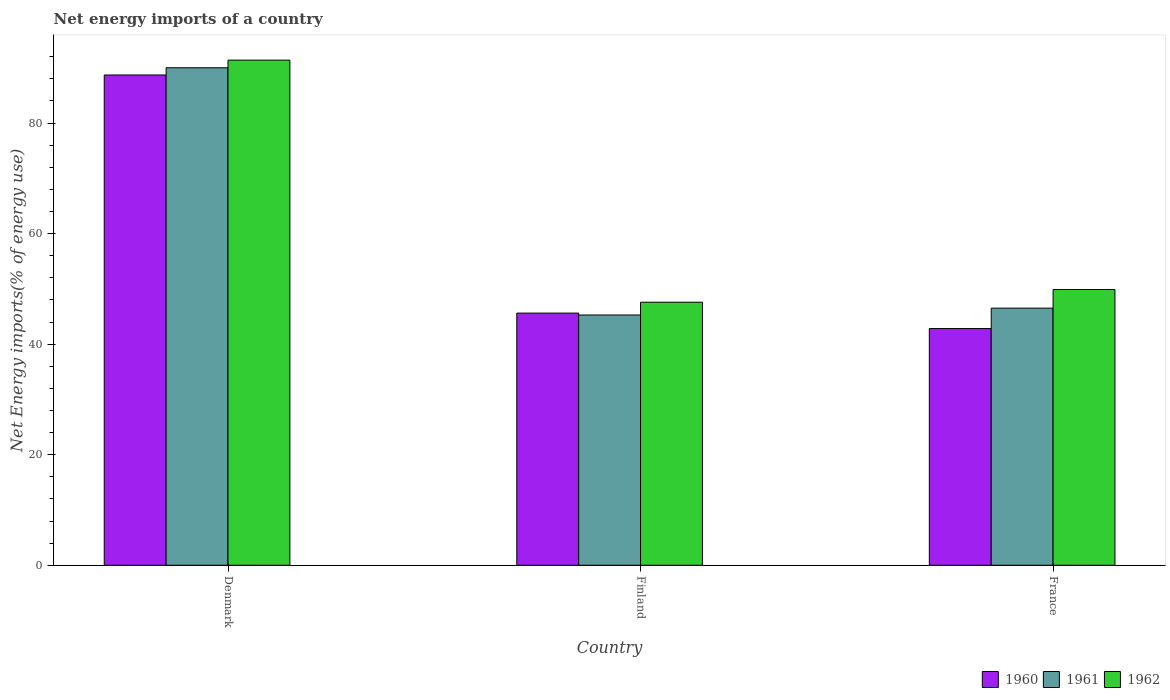How many different coloured bars are there?
Your response must be concise. 3. How many groups of bars are there?
Your answer should be very brief. 3. Are the number of bars per tick equal to the number of legend labels?
Make the answer very short. Yes. How many bars are there on the 3rd tick from the left?
Your answer should be compact. 3. What is the label of the 1st group of bars from the left?
Your answer should be very brief. Denmark. In how many cases, is the number of bars for a given country not equal to the number of legend labels?
Provide a short and direct response. 0. What is the net energy imports in 1960 in Denmark?
Your response must be concise. 88.7. Across all countries, what is the maximum net energy imports in 1962?
Your response must be concise. 91.39. Across all countries, what is the minimum net energy imports in 1960?
Your response must be concise. 42.82. In which country was the net energy imports in 1960 minimum?
Ensure brevity in your answer.  France. What is the total net energy imports in 1961 in the graph?
Your answer should be very brief. 181.81. What is the difference between the net energy imports in 1962 in Denmark and that in Finland?
Your response must be concise. 43.8. What is the difference between the net energy imports in 1962 in France and the net energy imports in 1961 in Denmark?
Ensure brevity in your answer.  -40.12. What is the average net energy imports in 1962 per country?
Your answer should be very brief. 62.96. What is the difference between the net energy imports of/in 1961 and net energy imports of/in 1962 in Finland?
Your answer should be very brief. -2.31. In how many countries, is the net energy imports in 1960 greater than 56 %?
Provide a succinct answer. 1. What is the ratio of the net energy imports in 1960 in Denmark to that in Finland?
Keep it short and to the point. 1.94. Is the net energy imports in 1960 in Denmark less than that in Finland?
Provide a short and direct response. No. Is the difference between the net energy imports in 1961 in Finland and France greater than the difference between the net energy imports in 1962 in Finland and France?
Provide a succinct answer. Yes. What is the difference between the highest and the second highest net energy imports in 1960?
Keep it short and to the point. 45.88. What is the difference between the highest and the lowest net energy imports in 1961?
Your answer should be compact. 44.73. In how many countries, is the net energy imports in 1960 greater than the average net energy imports in 1960 taken over all countries?
Give a very brief answer. 1. What does the 1st bar from the right in France represents?
Make the answer very short. 1962. Is it the case that in every country, the sum of the net energy imports in 1961 and net energy imports in 1960 is greater than the net energy imports in 1962?
Offer a terse response. Yes. What is the difference between two consecutive major ticks on the Y-axis?
Your response must be concise. 20. How many legend labels are there?
Your answer should be very brief. 3. What is the title of the graph?
Ensure brevity in your answer.  Net energy imports of a country. Does "2009" appear as one of the legend labels in the graph?
Give a very brief answer. No. What is the label or title of the Y-axis?
Provide a succinct answer. Net Energy imports(% of energy use). What is the Net Energy imports(% of energy use) of 1960 in Denmark?
Your answer should be very brief. 88.7. What is the Net Energy imports(% of energy use) of 1961 in Denmark?
Provide a short and direct response. 90.01. What is the Net Energy imports(% of energy use) in 1962 in Denmark?
Offer a terse response. 91.39. What is the Net Energy imports(% of energy use) in 1960 in Finland?
Make the answer very short. 45.62. What is the Net Energy imports(% of energy use) in 1961 in Finland?
Your answer should be compact. 45.28. What is the Net Energy imports(% of energy use) of 1962 in Finland?
Provide a succinct answer. 47.59. What is the Net Energy imports(% of energy use) of 1960 in France?
Offer a very short reply. 42.82. What is the Net Energy imports(% of energy use) in 1961 in France?
Provide a succinct answer. 46.52. What is the Net Energy imports(% of energy use) of 1962 in France?
Provide a succinct answer. 49.89. Across all countries, what is the maximum Net Energy imports(% of energy use) in 1960?
Give a very brief answer. 88.7. Across all countries, what is the maximum Net Energy imports(% of energy use) in 1961?
Make the answer very short. 90.01. Across all countries, what is the maximum Net Energy imports(% of energy use) in 1962?
Make the answer very short. 91.39. Across all countries, what is the minimum Net Energy imports(% of energy use) in 1960?
Make the answer very short. 42.82. Across all countries, what is the minimum Net Energy imports(% of energy use) of 1961?
Keep it short and to the point. 45.28. Across all countries, what is the minimum Net Energy imports(% of energy use) of 1962?
Ensure brevity in your answer.  47.59. What is the total Net Energy imports(% of energy use) in 1960 in the graph?
Ensure brevity in your answer.  177.14. What is the total Net Energy imports(% of energy use) of 1961 in the graph?
Make the answer very short. 181.81. What is the total Net Energy imports(% of energy use) in 1962 in the graph?
Ensure brevity in your answer.  188.87. What is the difference between the Net Energy imports(% of energy use) of 1960 in Denmark and that in Finland?
Your response must be concise. 43.08. What is the difference between the Net Energy imports(% of energy use) of 1961 in Denmark and that in Finland?
Provide a short and direct response. 44.73. What is the difference between the Net Energy imports(% of energy use) of 1962 in Denmark and that in Finland?
Provide a short and direct response. 43.8. What is the difference between the Net Energy imports(% of energy use) of 1960 in Denmark and that in France?
Keep it short and to the point. 45.88. What is the difference between the Net Energy imports(% of energy use) of 1961 in Denmark and that in France?
Offer a terse response. 43.49. What is the difference between the Net Energy imports(% of energy use) in 1962 in Denmark and that in France?
Ensure brevity in your answer.  41.5. What is the difference between the Net Energy imports(% of energy use) of 1960 in Finland and that in France?
Your answer should be very brief. 2.8. What is the difference between the Net Energy imports(% of energy use) in 1961 in Finland and that in France?
Provide a succinct answer. -1.24. What is the difference between the Net Energy imports(% of energy use) in 1962 in Finland and that in France?
Provide a short and direct response. -2.3. What is the difference between the Net Energy imports(% of energy use) of 1960 in Denmark and the Net Energy imports(% of energy use) of 1961 in Finland?
Give a very brief answer. 43.42. What is the difference between the Net Energy imports(% of energy use) in 1960 in Denmark and the Net Energy imports(% of energy use) in 1962 in Finland?
Provide a short and direct response. 41.11. What is the difference between the Net Energy imports(% of energy use) in 1961 in Denmark and the Net Energy imports(% of energy use) in 1962 in Finland?
Keep it short and to the point. 42.42. What is the difference between the Net Energy imports(% of energy use) in 1960 in Denmark and the Net Energy imports(% of energy use) in 1961 in France?
Your response must be concise. 42.18. What is the difference between the Net Energy imports(% of energy use) of 1960 in Denmark and the Net Energy imports(% of energy use) of 1962 in France?
Give a very brief answer. 38.81. What is the difference between the Net Energy imports(% of energy use) of 1961 in Denmark and the Net Energy imports(% of energy use) of 1962 in France?
Offer a very short reply. 40.12. What is the difference between the Net Energy imports(% of energy use) of 1960 in Finland and the Net Energy imports(% of energy use) of 1961 in France?
Make the answer very short. -0.9. What is the difference between the Net Energy imports(% of energy use) of 1960 in Finland and the Net Energy imports(% of energy use) of 1962 in France?
Provide a short and direct response. -4.27. What is the difference between the Net Energy imports(% of energy use) of 1961 in Finland and the Net Energy imports(% of energy use) of 1962 in France?
Make the answer very short. -4.61. What is the average Net Energy imports(% of energy use) in 1960 per country?
Ensure brevity in your answer.  59.05. What is the average Net Energy imports(% of energy use) in 1961 per country?
Give a very brief answer. 60.6. What is the average Net Energy imports(% of energy use) in 1962 per country?
Provide a succinct answer. 62.96. What is the difference between the Net Energy imports(% of energy use) in 1960 and Net Energy imports(% of energy use) in 1961 in Denmark?
Provide a succinct answer. -1.31. What is the difference between the Net Energy imports(% of energy use) in 1960 and Net Energy imports(% of energy use) in 1962 in Denmark?
Your answer should be compact. -2.69. What is the difference between the Net Energy imports(% of energy use) in 1961 and Net Energy imports(% of energy use) in 1962 in Denmark?
Your response must be concise. -1.38. What is the difference between the Net Energy imports(% of energy use) of 1960 and Net Energy imports(% of energy use) of 1961 in Finland?
Your answer should be very brief. 0.34. What is the difference between the Net Energy imports(% of energy use) of 1960 and Net Energy imports(% of energy use) of 1962 in Finland?
Offer a very short reply. -1.97. What is the difference between the Net Energy imports(% of energy use) in 1961 and Net Energy imports(% of energy use) in 1962 in Finland?
Offer a terse response. -2.31. What is the difference between the Net Energy imports(% of energy use) of 1960 and Net Energy imports(% of energy use) of 1961 in France?
Offer a terse response. -3.7. What is the difference between the Net Energy imports(% of energy use) of 1960 and Net Energy imports(% of energy use) of 1962 in France?
Offer a very short reply. -7.06. What is the difference between the Net Energy imports(% of energy use) in 1961 and Net Energy imports(% of energy use) in 1962 in France?
Your answer should be very brief. -3.37. What is the ratio of the Net Energy imports(% of energy use) in 1960 in Denmark to that in Finland?
Your answer should be compact. 1.94. What is the ratio of the Net Energy imports(% of energy use) in 1961 in Denmark to that in Finland?
Your answer should be compact. 1.99. What is the ratio of the Net Energy imports(% of energy use) in 1962 in Denmark to that in Finland?
Keep it short and to the point. 1.92. What is the ratio of the Net Energy imports(% of energy use) of 1960 in Denmark to that in France?
Offer a terse response. 2.07. What is the ratio of the Net Energy imports(% of energy use) in 1961 in Denmark to that in France?
Your response must be concise. 1.93. What is the ratio of the Net Energy imports(% of energy use) in 1962 in Denmark to that in France?
Keep it short and to the point. 1.83. What is the ratio of the Net Energy imports(% of energy use) of 1960 in Finland to that in France?
Your answer should be compact. 1.07. What is the ratio of the Net Energy imports(% of energy use) in 1961 in Finland to that in France?
Provide a succinct answer. 0.97. What is the ratio of the Net Energy imports(% of energy use) in 1962 in Finland to that in France?
Offer a very short reply. 0.95. What is the difference between the highest and the second highest Net Energy imports(% of energy use) of 1960?
Provide a short and direct response. 43.08. What is the difference between the highest and the second highest Net Energy imports(% of energy use) in 1961?
Ensure brevity in your answer.  43.49. What is the difference between the highest and the second highest Net Energy imports(% of energy use) in 1962?
Offer a terse response. 41.5. What is the difference between the highest and the lowest Net Energy imports(% of energy use) of 1960?
Keep it short and to the point. 45.88. What is the difference between the highest and the lowest Net Energy imports(% of energy use) in 1961?
Your answer should be compact. 44.73. What is the difference between the highest and the lowest Net Energy imports(% of energy use) in 1962?
Provide a short and direct response. 43.8. 